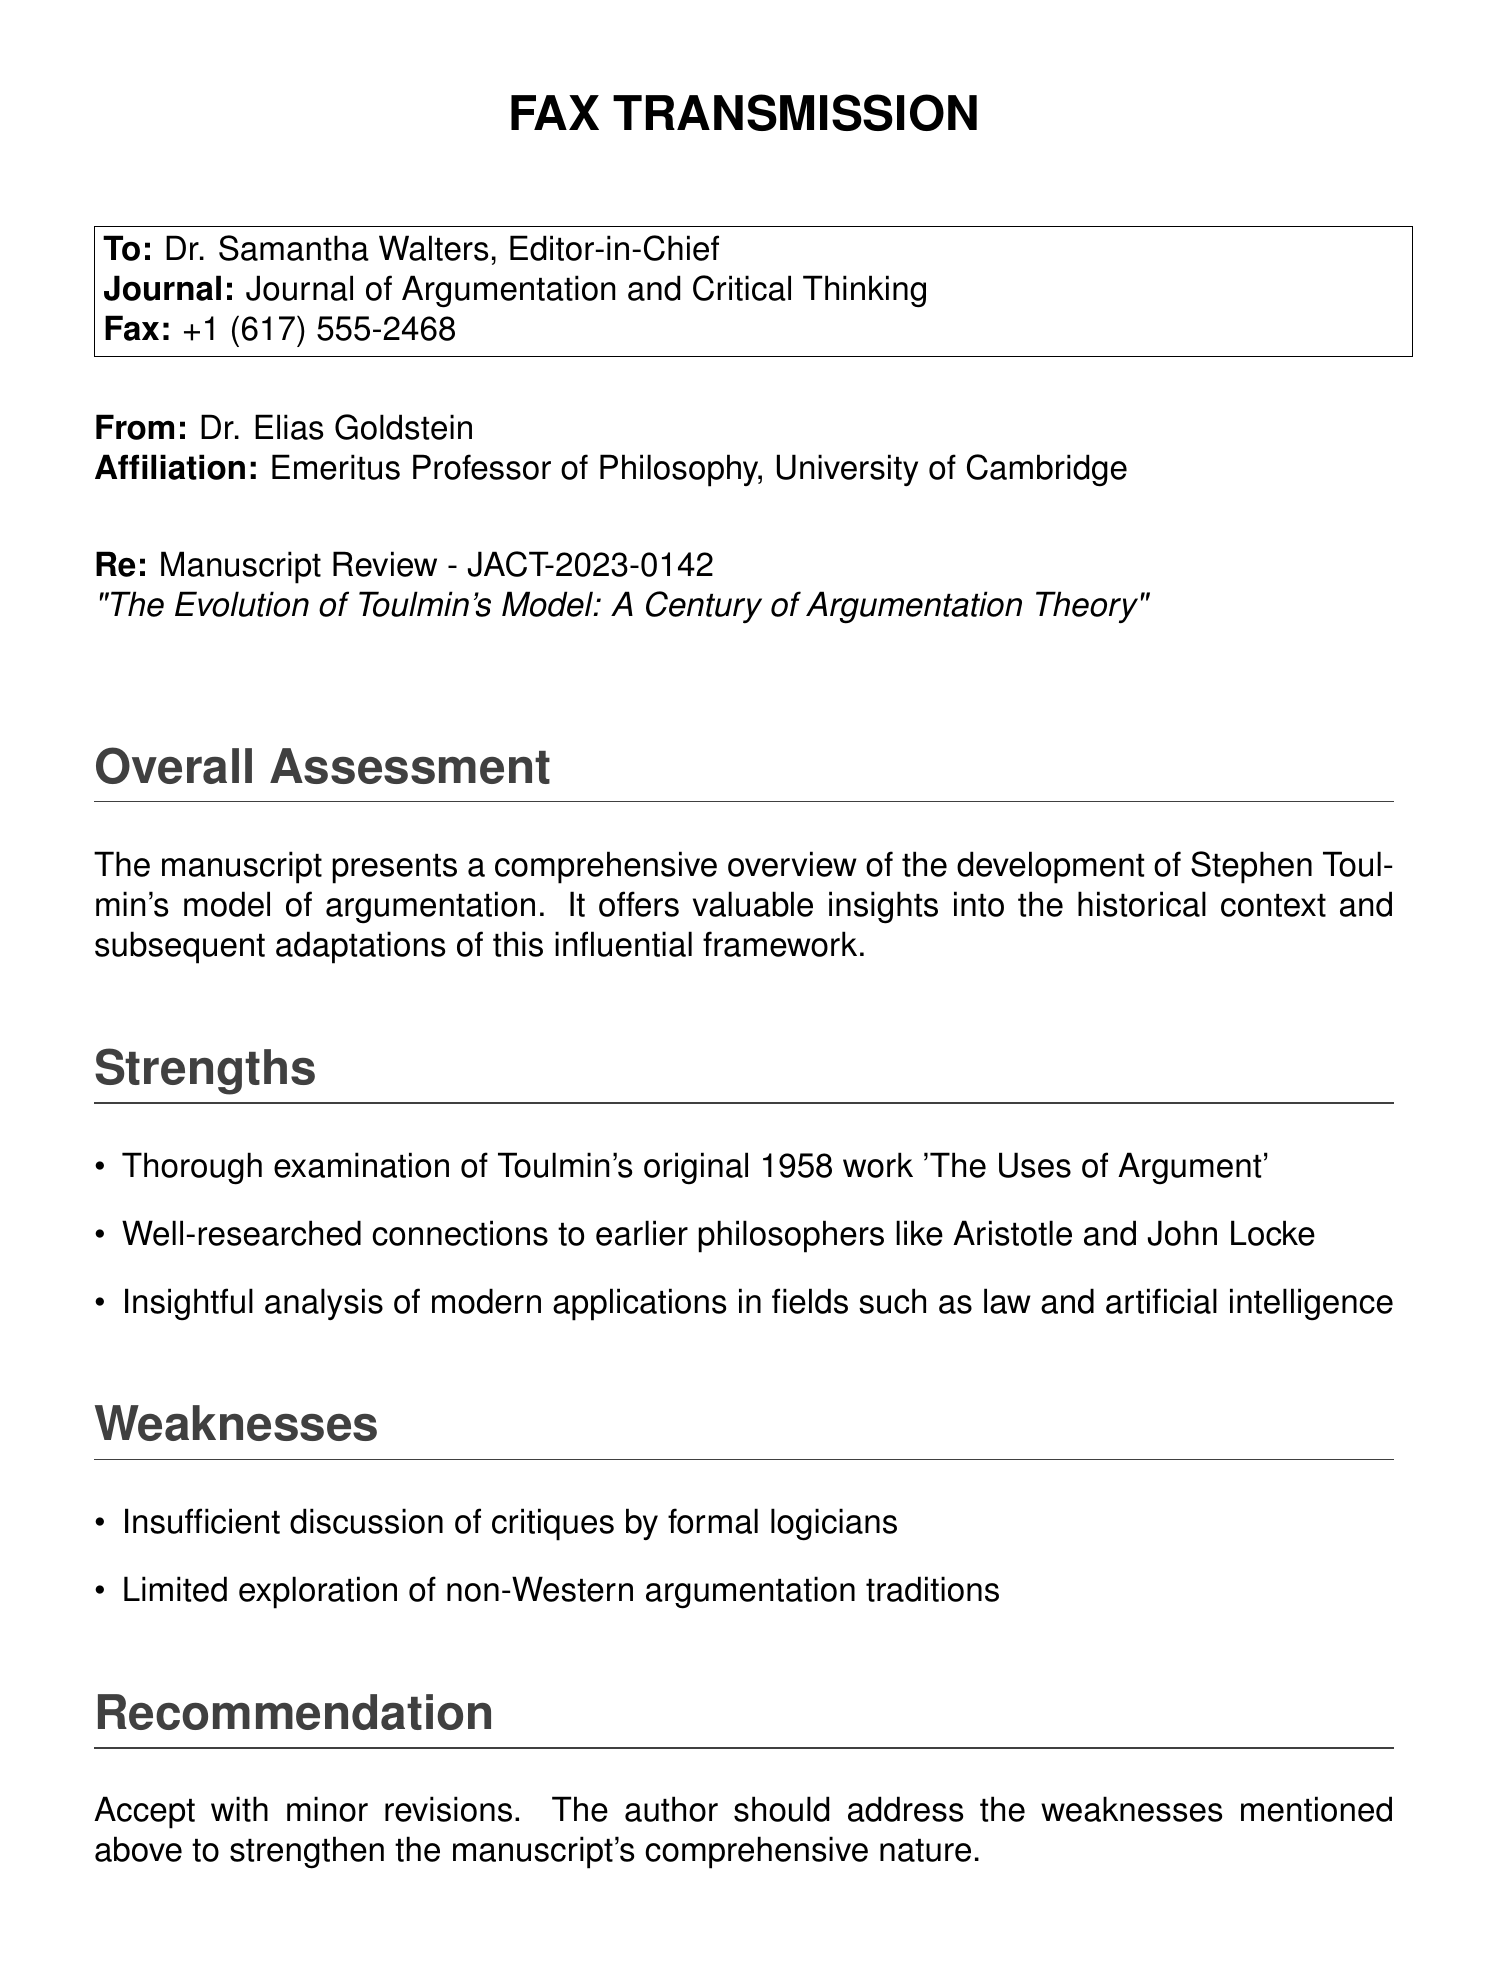What is the recipient's name? The recipient of the fax is addressed in the document, which lists Dr. Samantha Walters as the Editor-in-Chief.
Answer: Dr. Samantha Walters What is the manuscript identification number? The document refers to the manuscript using a specific identification number which is JACT-2023-0142.
Answer: JACT-2023-0142 Who authored the manuscript? The fax is from Dr. Elias Goldstein, indicating he is the author of the manuscript being reviewed.
Answer: Dr. Elias Goldstein What date was the fax sent? The date of the fax is mentioned at the end of the document, indicating when it was sent.
Answer: May 15, 2023 What is one strength of the manuscript? Among the strengths listed, the thorough examination of Toulmin's original work is highlighted.
Answer: Thorough examination of Toulmin's original 1958 work 'The Uses of Argument' What is one weakness of the manuscript? The document mentions that there is insufficient discussion of critiques by formal logicians as a weakness.
Answer: Insufficient discussion of critiques by formal logicians What is the recommendation for the manuscript? The recommendation provided indicates the general decision regarding the manuscript after review.
Answer: Accept with minor revisions What is the title of the manuscript? The title of the manuscript is clearly stated in the document for context.
Answer: The Evolution of Toulmin's Model: A Century of Argumentation Theory What affiliation is listed for the sender? The sender's affiliation is provided in the fax, indicating his professional status.
Answer: Emeritus Professor of Philosophy, University of Cambridge 